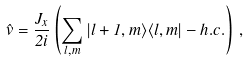Convert formula to latex. <formula><loc_0><loc_0><loc_500><loc_500>\hat { v } = \frac { J _ { x } } { 2 i } \left ( \sum _ { l , m } | l + 1 , m \rangle \langle l , m | - h . c . \right ) \, ,</formula> 